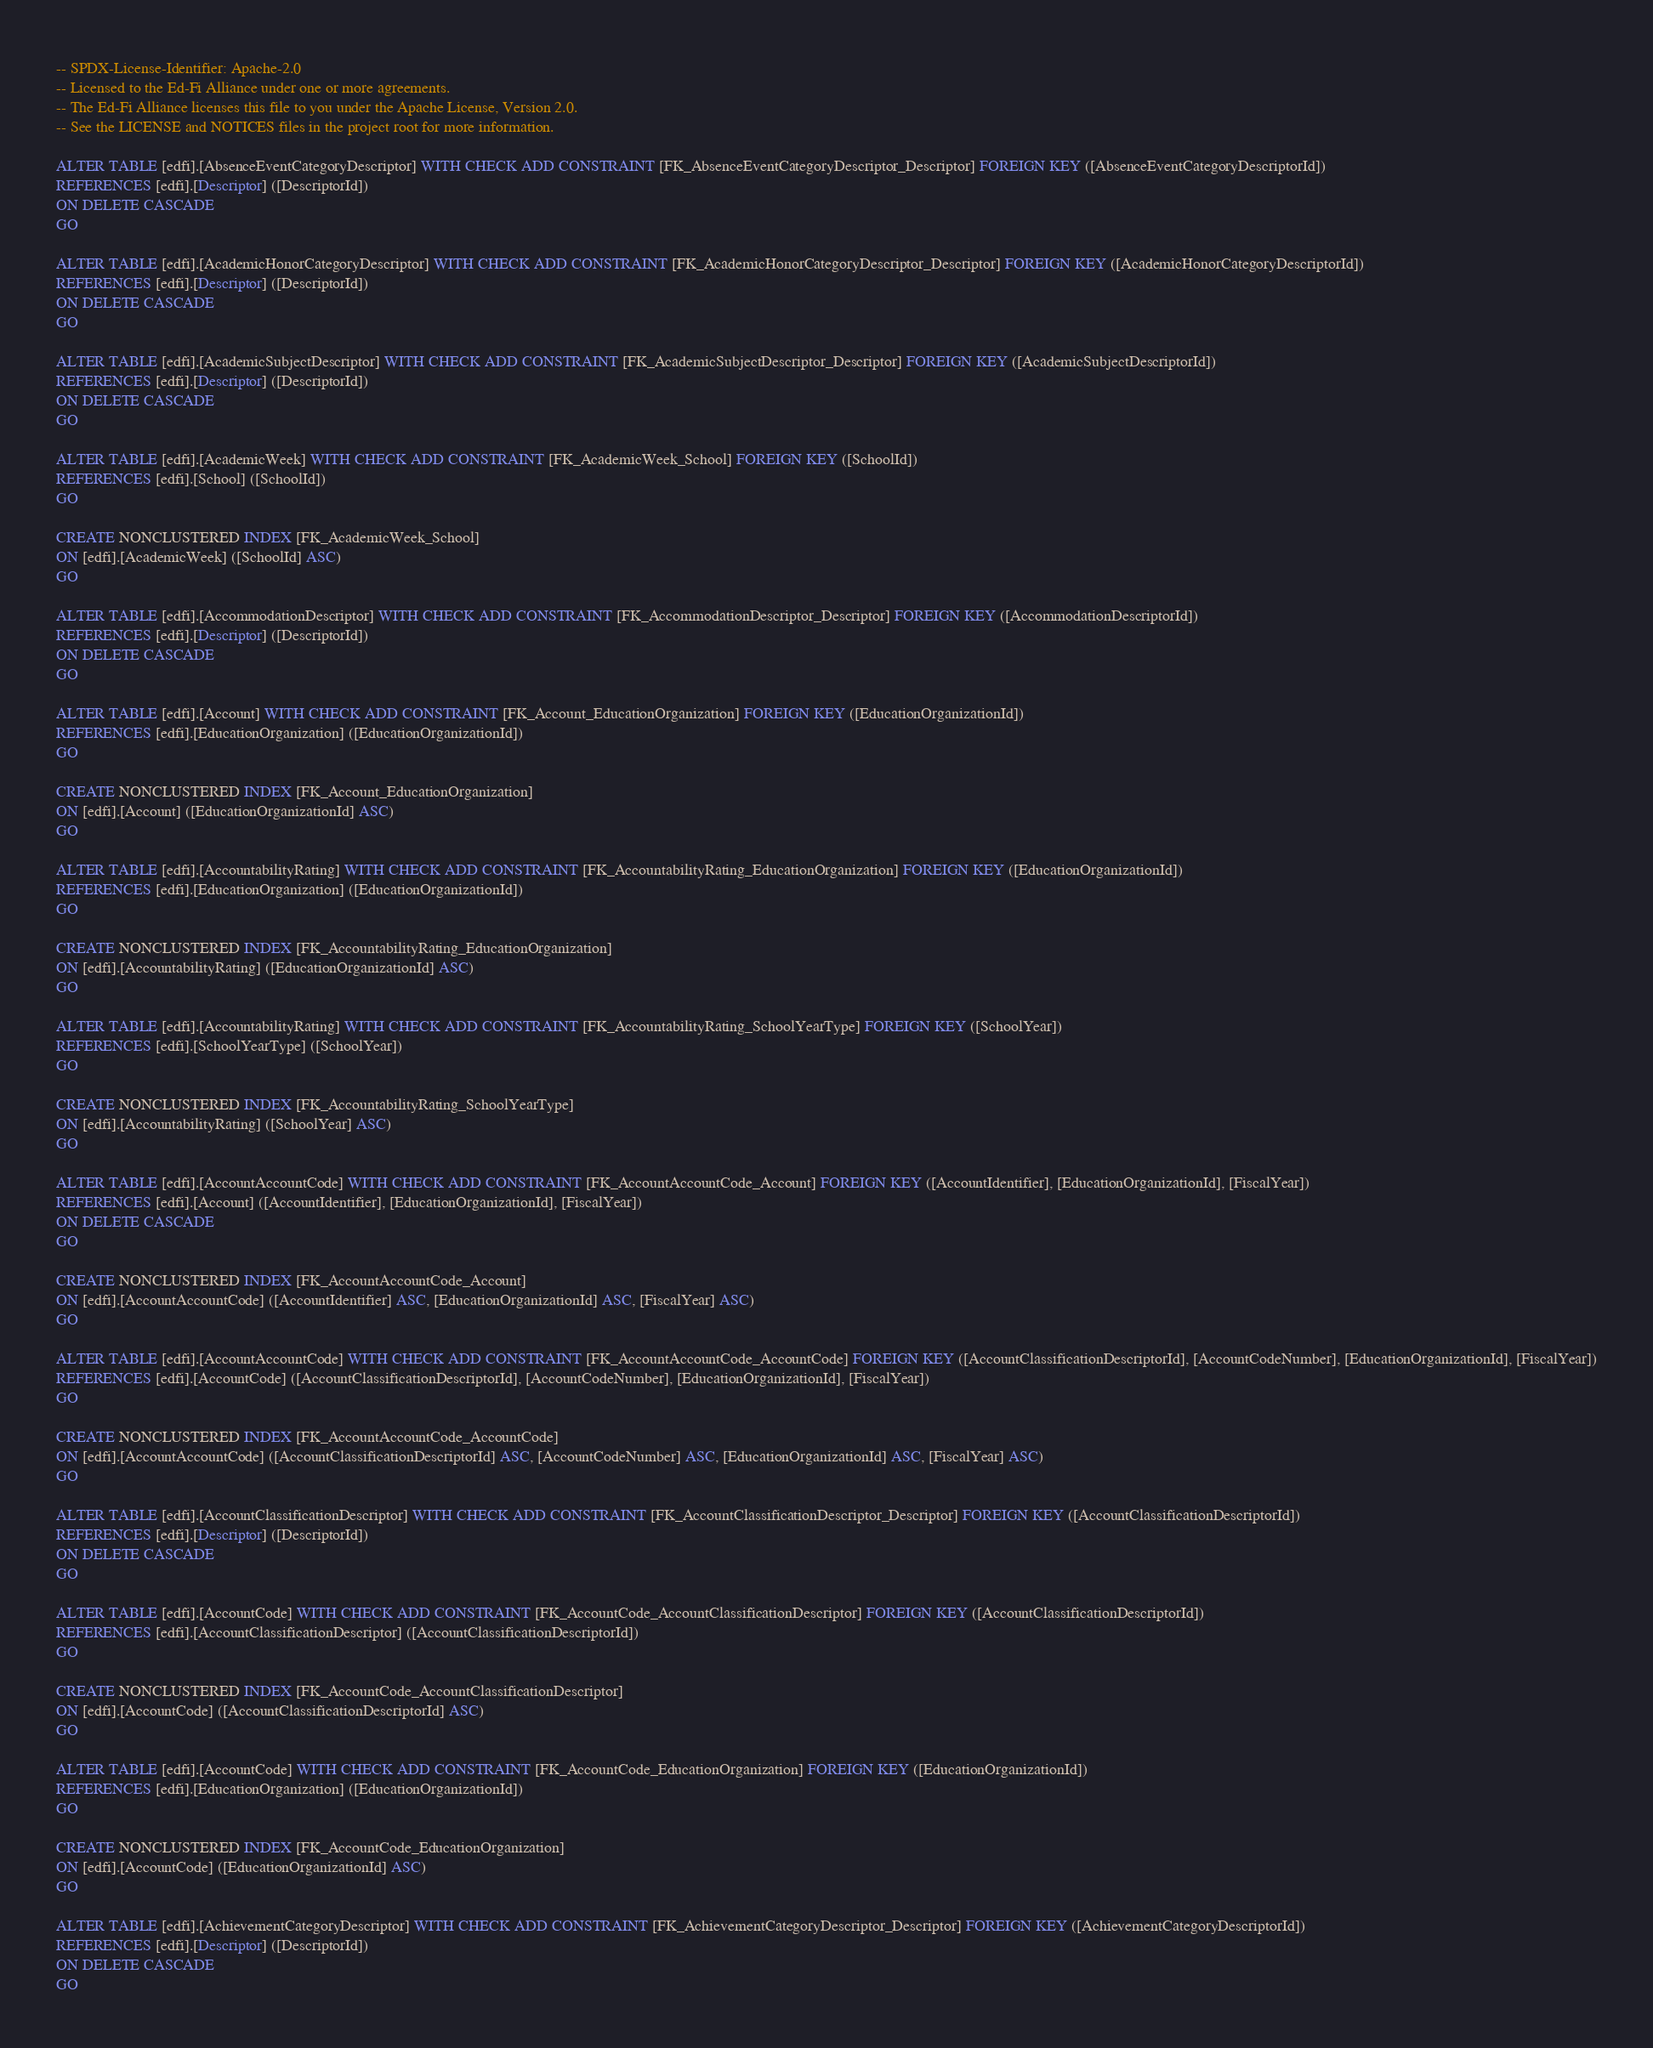<code> <loc_0><loc_0><loc_500><loc_500><_SQL_>-- SPDX-License-Identifier: Apache-2.0
-- Licensed to the Ed-Fi Alliance under one or more agreements.
-- The Ed-Fi Alliance licenses this file to you under the Apache License, Version 2.0.
-- See the LICENSE and NOTICES files in the project root for more information.

ALTER TABLE [edfi].[AbsenceEventCategoryDescriptor] WITH CHECK ADD CONSTRAINT [FK_AbsenceEventCategoryDescriptor_Descriptor] FOREIGN KEY ([AbsenceEventCategoryDescriptorId])
REFERENCES [edfi].[Descriptor] ([DescriptorId])
ON DELETE CASCADE
GO

ALTER TABLE [edfi].[AcademicHonorCategoryDescriptor] WITH CHECK ADD CONSTRAINT [FK_AcademicHonorCategoryDescriptor_Descriptor] FOREIGN KEY ([AcademicHonorCategoryDescriptorId])
REFERENCES [edfi].[Descriptor] ([DescriptorId])
ON DELETE CASCADE
GO

ALTER TABLE [edfi].[AcademicSubjectDescriptor] WITH CHECK ADD CONSTRAINT [FK_AcademicSubjectDescriptor_Descriptor] FOREIGN KEY ([AcademicSubjectDescriptorId])
REFERENCES [edfi].[Descriptor] ([DescriptorId])
ON DELETE CASCADE
GO

ALTER TABLE [edfi].[AcademicWeek] WITH CHECK ADD CONSTRAINT [FK_AcademicWeek_School] FOREIGN KEY ([SchoolId])
REFERENCES [edfi].[School] ([SchoolId])
GO

CREATE NONCLUSTERED INDEX [FK_AcademicWeek_School]
ON [edfi].[AcademicWeek] ([SchoolId] ASC)
GO

ALTER TABLE [edfi].[AccommodationDescriptor] WITH CHECK ADD CONSTRAINT [FK_AccommodationDescriptor_Descriptor] FOREIGN KEY ([AccommodationDescriptorId])
REFERENCES [edfi].[Descriptor] ([DescriptorId])
ON DELETE CASCADE
GO

ALTER TABLE [edfi].[Account] WITH CHECK ADD CONSTRAINT [FK_Account_EducationOrganization] FOREIGN KEY ([EducationOrganizationId])
REFERENCES [edfi].[EducationOrganization] ([EducationOrganizationId])
GO

CREATE NONCLUSTERED INDEX [FK_Account_EducationOrganization]
ON [edfi].[Account] ([EducationOrganizationId] ASC)
GO

ALTER TABLE [edfi].[AccountabilityRating] WITH CHECK ADD CONSTRAINT [FK_AccountabilityRating_EducationOrganization] FOREIGN KEY ([EducationOrganizationId])
REFERENCES [edfi].[EducationOrganization] ([EducationOrganizationId])
GO

CREATE NONCLUSTERED INDEX [FK_AccountabilityRating_EducationOrganization]
ON [edfi].[AccountabilityRating] ([EducationOrganizationId] ASC)
GO

ALTER TABLE [edfi].[AccountabilityRating] WITH CHECK ADD CONSTRAINT [FK_AccountabilityRating_SchoolYearType] FOREIGN KEY ([SchoolYear])
REFERENCES [edfi].[SchoolYearType] ([SchoolYear])
GO

CREATE NONCLUSTERED INDEX [FK_AccountabilityRating_SchoolYearType]
ON [edfi].[AccountabilityRating] ([SchoolYear] ASC)
GO

ALTER TABLE [edfi].[AccountAccountCode] WITH CHECK ADD CONSTRAINT [FK_AccountAccountCode_Account] FOREIGN KEY ([AccountIdentifier], [EducationOrganizationId], [FiscalYear])
REFERENCES [edfi].[Account] ([AccountIdentifier], [EducationOrganizationId], [FiscalYear])
ON DELETE CASCADE
GO

CREATE NONCLUSTERED INDEX [FK_AccountAccountCode_Account]
ON [edfi].[AccountAccountCode] ([AccountIdentifier] ASC, [EducationOrganizationId] ASC, [FiscalYear] ASC)
GO

ALTER TABLE [edfi].[AccountAccountCode] WITH CHECK ADD CONSTRAINT [FK_AccountAccountCode_AccountCode] FOREIGN KEY ([AccountClassificationDescriptorId], [AccountCodeNumber], [EducationOrganizationId], [FiscalYear])
REFERENCES [edfi].[AccountCode] ([AccountClassificationDescriptorId], [AccountCodeNumber], [EducationOrganizationId], [FiscalYear])
GO

CREATE NONCLUSTERED INDEX [FK_AccountAccountCode_AccountCode]
ON [edfi].[AccountAccountCode] ([AccountClassificationDescriptorId] ASC, [AccountCodeNumber] ASC, [EducationOrganizationId] ASC, [FiscalYear] ASC)
GO

ALTER TABLE [edfi].[AccountClassificationDescriptor] WITH CHECK ADD CONSTRAINT [FK_AccountClassificationDescriptor_Descriptor] FOREIGN KEY ([AccountClassificationDescriptorId])
REFERENCES [edfi].[Descriptor] ([DescriptorId])
ON DELETE CASCADE
GO

ALTER TABLE [edfi].[AccountCode] WITH CHECK ADD CONSTRAINT [FK_AccountCode_AccountClassificationDescriptor] FOREIGN KEY ([AccountClassificationDescriptorId])
REFERENCES [edfi].[AccountClassificationDescriptor] ([AccountClassificationDescriptorId])
GO

CREATE NONCLUSTERED INDEX [FK_AccountCode_AccountClassificationDescriptor]
ON [edfi].[AccountCode] ([AccountClassificationDescriptorId] ASC)
GO

ALTER TABLE [edfi].[AccountCode] WITH CHECK ADD CONSTRAINT [FK_AccountCode_EducationOrganization] FOREIGN KEY ([EducationOrganizationId])
REFERENCES [edfi].[EducationOrganization] ([EducationOrganizationId])
GO

CREATE NONCLUSTERED INDEX [FK_AccountCode_EducationOrganization]
ON [edfi].[AccountCode] ([EducationOrganizationId] ASC)
GO

ALTER TABLE [edfi].[AchievementCategoryDescriptor] WITH CHECK ADD CONSTRAINT [FK_AchievementCategoryDescriptor_Descriptor] FOREIGN KEY ([AchievementCategoryDescriptorId])
REFERENCES [edfi].[Descriptor] ([DescriptorId])
ON DELETE CASCADE
GO
</code> 